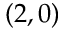Convert formula to latex. <formula><loc_0><loc_0><loc_500><loc_500>( 2 , 0 )</formula> 